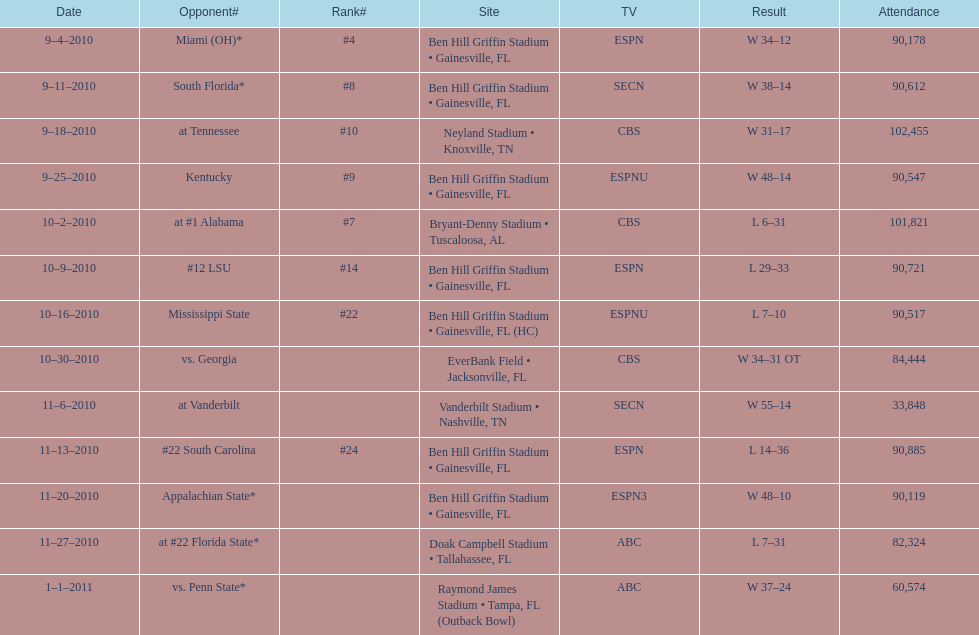Which television channel broadcasted the highest number of games in the 2010/2011 season? ESPN. 